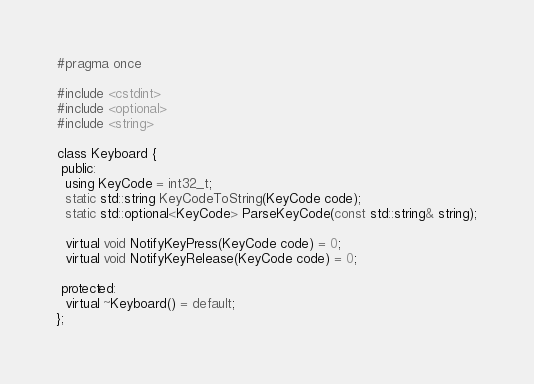<code> <loc_0><loc_0><loc_500><loc_500><_C_>#pragma once

#include <cstdint>
#include <optional>
#include <string>

class Keyboard {
 public:
  using KeyCode = int32_t;
  static std::string KeyCodeToString(KeyCode code);
  static std::optional<KeyCode> ParseKeyCode(const std::string& string);

  virtual void NotifyKeyPress(KeyCode code) = 0;
  virtual void NotifyKeyRelease(KeyCode code) = 0;

 protected:
  virtual ~Keyboard() = default;
};
</code> 